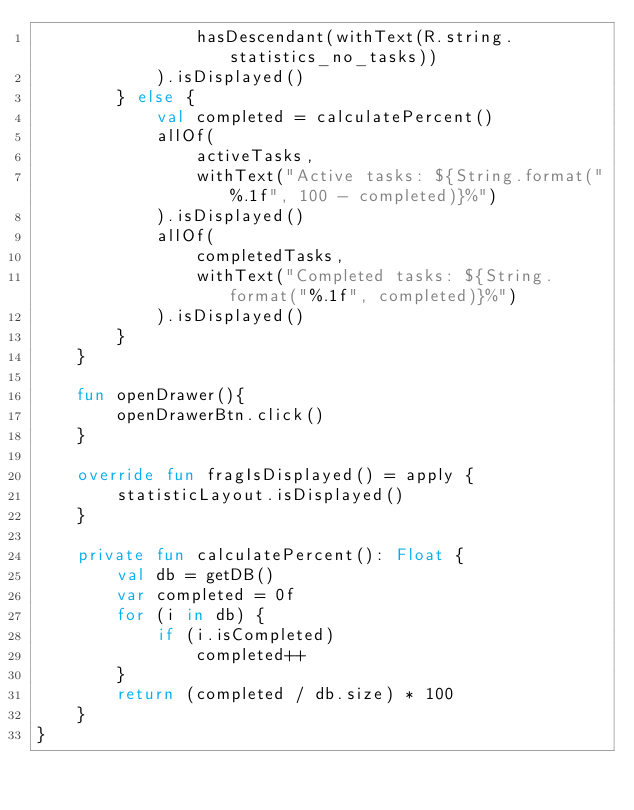Convert code to text. <code><loc_0><loc_0><loc_500><loc_500><_Kotlin_>                hasDescendant(withText(R.string.statistics_no_tasks))
            ).isDisplayed()
        } else {
            val completed = calculatePercent()
            allOf(
                activeTasks,
                withText("Active tasks: ${String.format("%.1f", 100 - completed)}%")
            ).isDisplayed()
            allOf(
                completedTasks,
                withText("Completed tasks: ${String.format("%.1f", completed)}%")
            ).isDisplayed()
        }
    }

    fun openDrawer(){
        openDrawerBtn.click()
    }

    override fun fragIsDisplayed() = apply {
        statisticLayout.isDisplayed()
    }

    private fun calculatePercent(): Float {
        val db = getDB()
        var completed = 0f
        for (i in db) {
            if (i.isCompleted)
                completed++
        }
        return (completed / db.size) * 100
    }
}</code> 